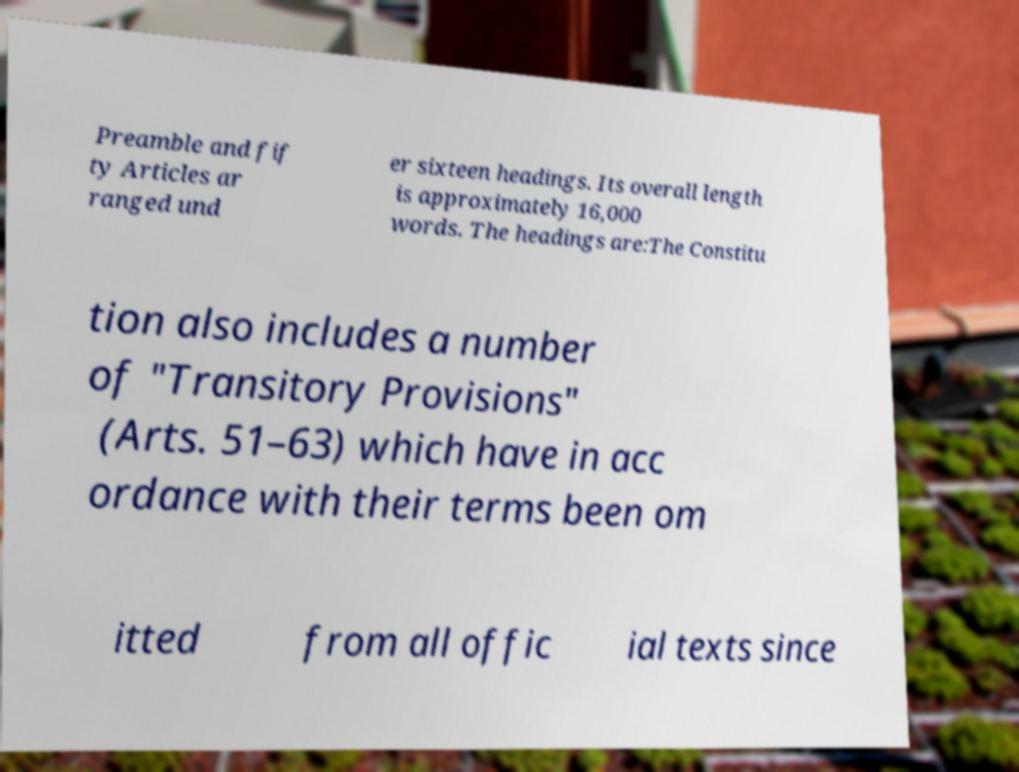Could you extract and type out the text from this image? Preamble and fif ty Articles ar ranged und er sixteen headings. Its overall length is approximately 16,000 words. The headings are:The Constitu tion also includes a number of "Transitory Provisions" (Arts. 51–63) which have in acc ordance with their terms been om itted from all offic ial texts since 